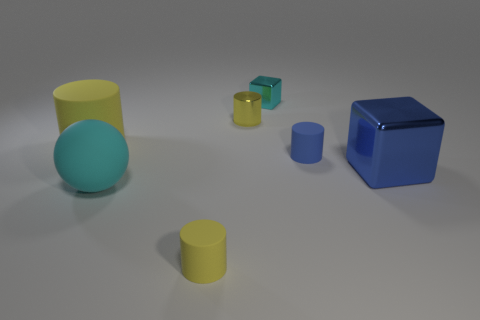Subtract all red balls. How many yellow cylinders are left? 3 Add 1 large rubber cylinders. How many objects exist? 8 Subtract all balls. How many objects are left? 6 Subtract all big spheres. Subtract all small blue cylinders. How many objects are left? 5 Add 1 tiny objects. How many tiny objects are left? 5 Add 1 small green cylinders. How many small green cylinders exist? 1 Subtract 0 cyan cylinders. How many objects are left? 7 